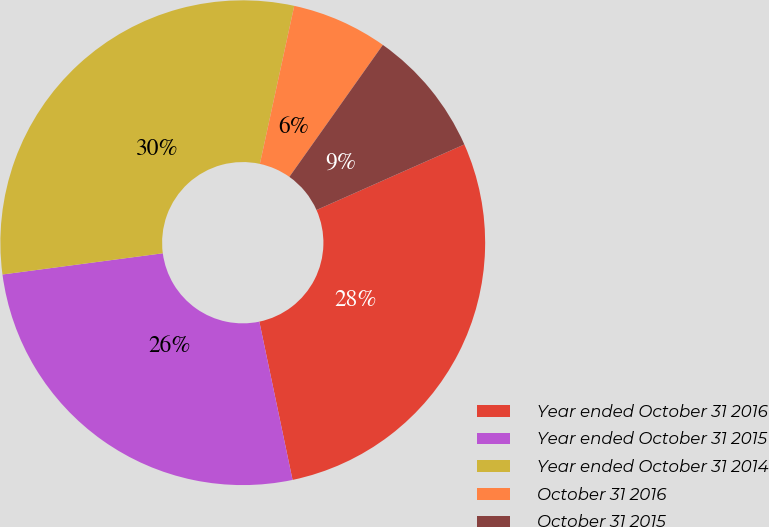Convert chart to OTSL. <chart><loc_0><loc_0><loc_500><loc_500><pie_chart><fcel>Year ended October 31 2016<fcel>Year ended October 31 2015<fcel>Year ended October 31 2014<fcel>October 31 2016<fcel>October 31 2015<nl><fcel>28.35%<fcel>26.2%<fcel>30.5%<fcel>6.4%<fcel>8.55%<nl></chart> 